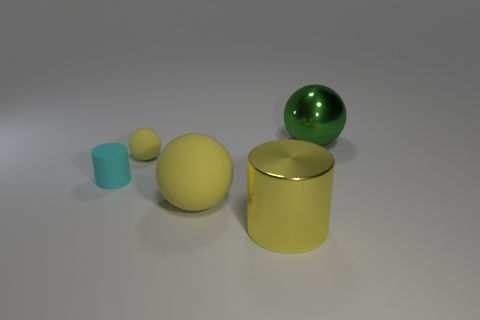How many objects are either rubber objects that are to the right of the cyan cylinder or big yellow things that are left of the big yellow metal cylinder? Upon review, there appears to be one large yellow rubber ball that is to the left of the big yellow metal cylinder. However, it is not possible to determine the materials of the objects definitively without more context. Therefore, while the number of objects fitting the description provided is at least one, the exact count cannot be ascertained without further information. 